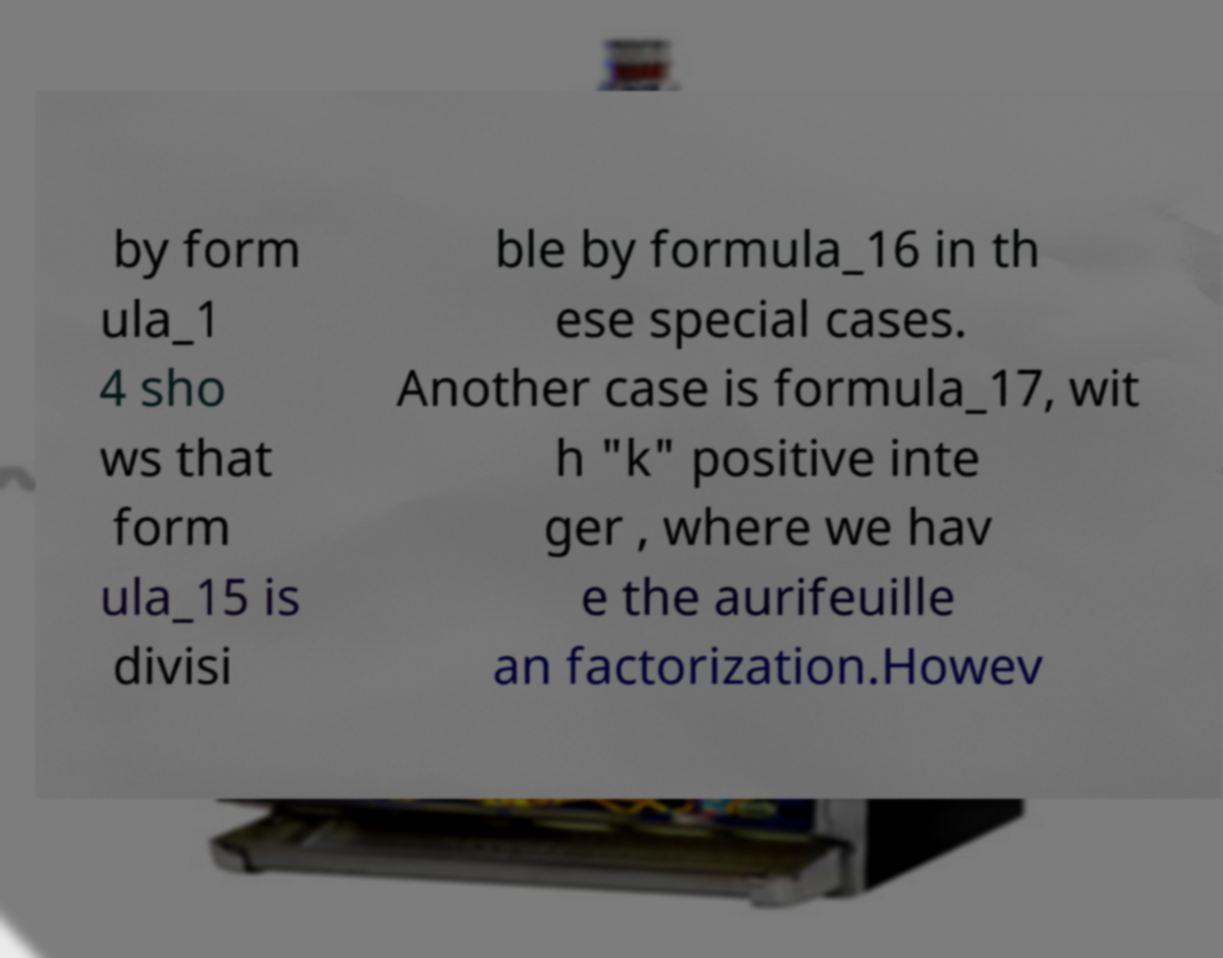Please read and relay the text visible in this image. What does it say? by form ula_1 4 sho ws that form ula_15 is divisi ble by formula_16 in th ese special cases. Another case is formula_17, wit h "k" positive inte ger , where we hav e the aurifeuille an factorization.Howev 